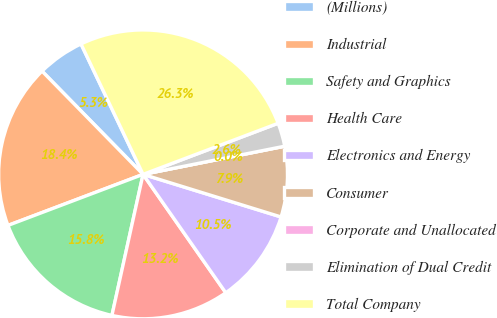Convert chart. <chart><loc_0><loc_0><loc_500><loc_500><pie_chart><fcel>(Millions)<fcel>Industrial<fcel>Safety and Graphics<fcel>Health Care<fcel>Electronics and Energy<fcel>Consumer<fcel>Corporate and Unallocated<fcel>Elimination of Dual Credit<fcel>Total Company<nl><fcel>5.26%<fcel>18.42%<fcel>15.79%<fcel>13.16%<fcel>10.53%<fcel>7.89%<fcel>0.0%<fcel>2.63%<fcel>26.31%<nl></chart> 